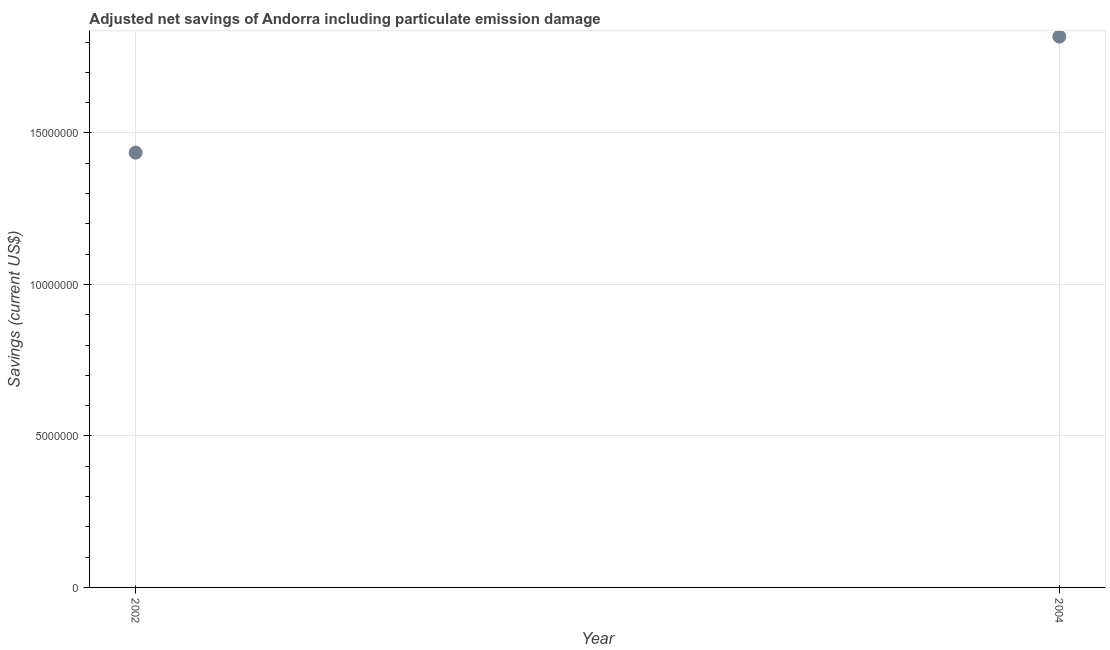What is the adjusted net savings in 2002?
Provide a short and direct response. 1.44e+07. Across all years, what is the maximum adjusted net savings?
Keep it short and to the point. 1.82e+07. Across all years, what is the minimum adjusted net savings?
Your response must be concise. 1.44e+07. In which year was the adjusted net savings minimum?
Provide a short and direct response. 2002. What is the sum of the adjusted net savings?
Make the answer very short. 3.25e+07. What is the difference between the adjusted net savings in 2002 and 2004?
Offer a very short reply. -3.83e+06. What is the average adjusted net savings per year?
Make the answer very short. 1.63e+07. What is the median adjusted net savings?
Make the answer very short. 1.63e+07. In how many years, is the adjusted net savings greater than 15000000 US$?
Provide a short and direct response. 1. What is the ratio of the adjusted net savings in 2002 to that in 2004?
Provide a short and direct response. 0.79. Does the adjusted net savings monotonically increase over the years?
Your answer should be compact. Yes. How many dotlines are there?
Make the answer very short. 1. Are the values on the major ticks of Y-axis written in scientific E-notation?
Your response must be concise. No. Does the graph contain grids?
Keep it short and to the point. Yes. What is the title of the graph?
Offer a very short reply. Adjusted net savings of Andorra including particulate emission damage. What is the label or title of the X-axis?
Offer a very short reply. Year. What is the label or title of the Y-axis?
Provide a short and direct response. Savings (current US$). What is the Savings (current US$) in 2002?
Your answer should be very brief. 1.44e+07. What is the Savings (current US$) in 2004?
Provide a succinct answer. 1.82e+07. What is the difference between the Savings (current US$) in 2002 and 2004?
Make the answer very short. -3.83e+06. What is the ratio of the Savings (current US$) in 2002 to that in 2004?
Give a very brief answer. 0.79. 